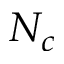<formula> <loc_0><loc_0><loc_500><loc_500>N _ { c }</formula> 